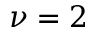Convert formula to latex. <formula><loc_0><loc_0><loc_500><loc_500>\nu = 2</formula> 